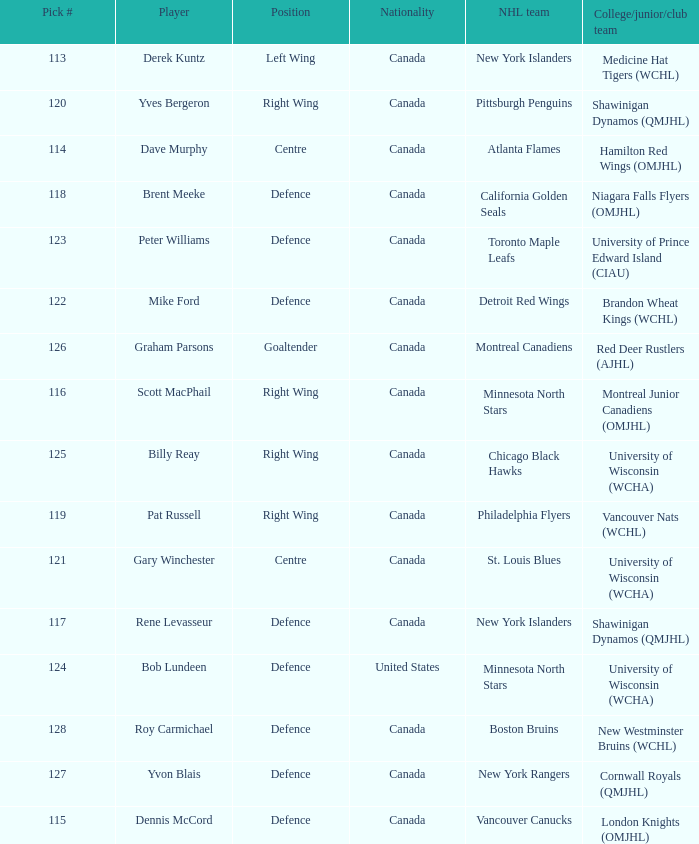Name the player for chicago black hawks Billy Reay. 